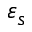Convert formula to latex. <formula><loc_0><loc_0><loc_500><loc_500>\varepsilon _ { s }</formula> 